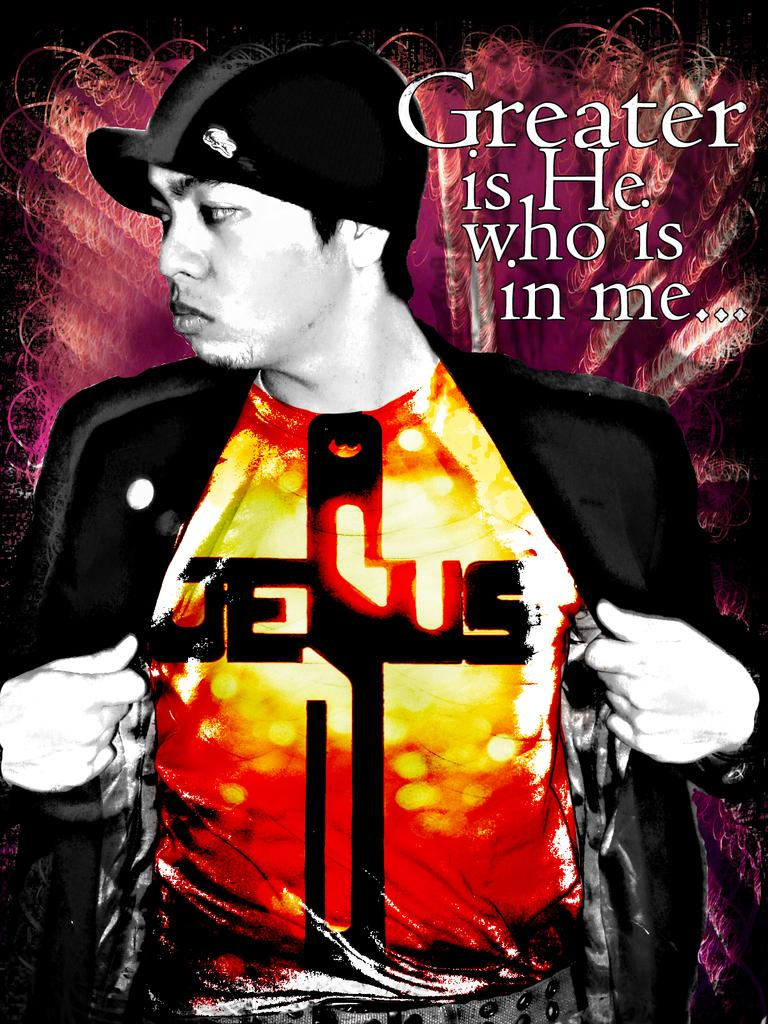<image>
Summarize the visual content of the image. A person is posing wearing a Jesus shirt. 